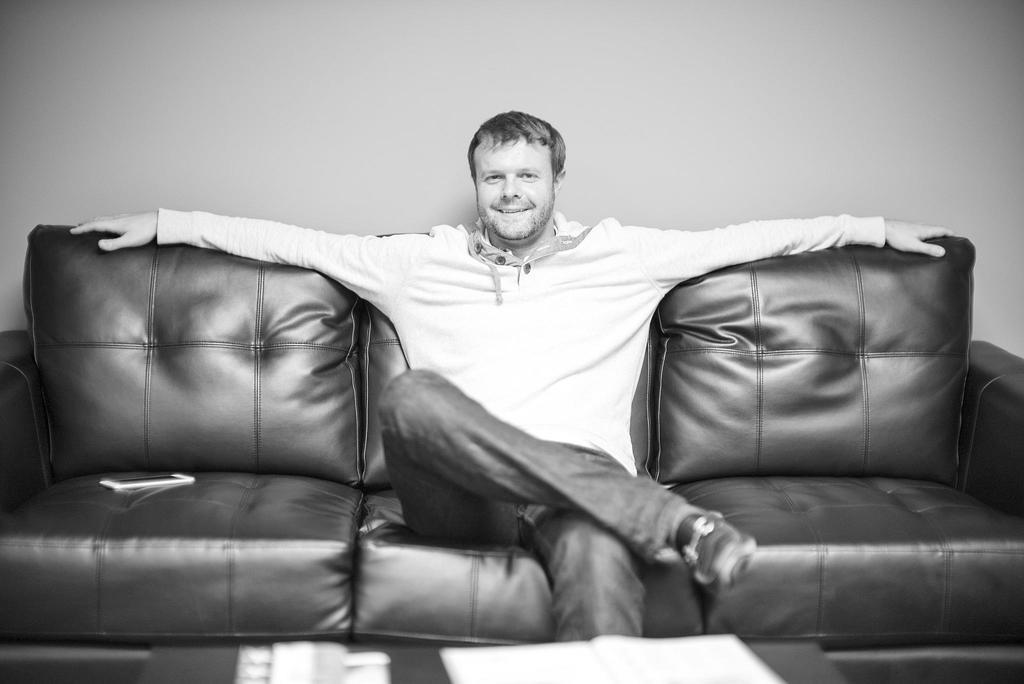Who or what is the main subject in the image? There is a person in the image. What is the person doing in the image? The person is sitting on a sofa. What is the person's facial expression in the image? The person is smiling. How many snakes are present in the image? There are no snakes present in the image; it features a person sitting on a sofa and smiling. Can you tell me what type of rabbit is sitting next to the person in the image? There is no rabbit present in the image. 